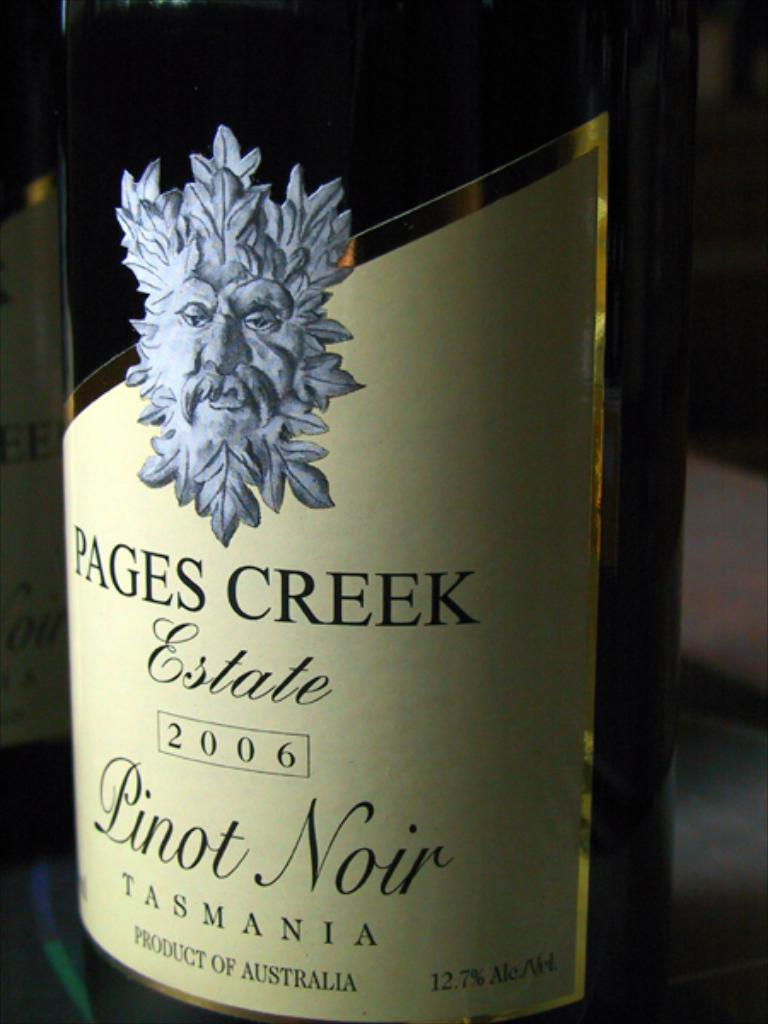<image>
Offer a succinct explanation of the picture presented. The text describes what kind of wine it is and the brand. 